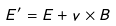Convert formula to latex. <formula><loc_0><loc_0><loc_500><loc_500>E ^ { \prime } = E + v \times B</formula> 